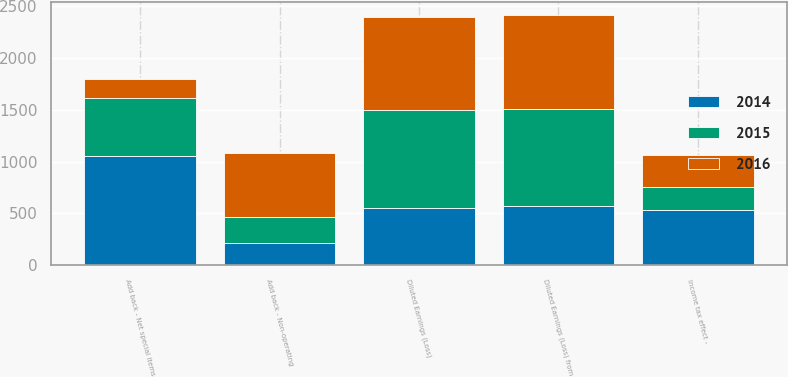<chart> <loc_0><loc_0><loc_500><loc_500><stacked_bar_chart><ecel><fcel>Diluted Earnings (Loss)<fcel>Diluted Earnings (Loss) from<fcel>Add back - Non-operating<fcel>Add back - Net special items<fcel>Income tax effect -<nl><fcel>2016<fcel>904<fcel>909<fcel>610<fcel>182<fcel>309<nl><fcel>2015<fcel>938<fcel>938<fcel>258<fcel>559<fcel>221<nl><fcel>2014<fcel>555<fcel>568<fcel>212<fcel>1052<fcel>536<nl></chart> 